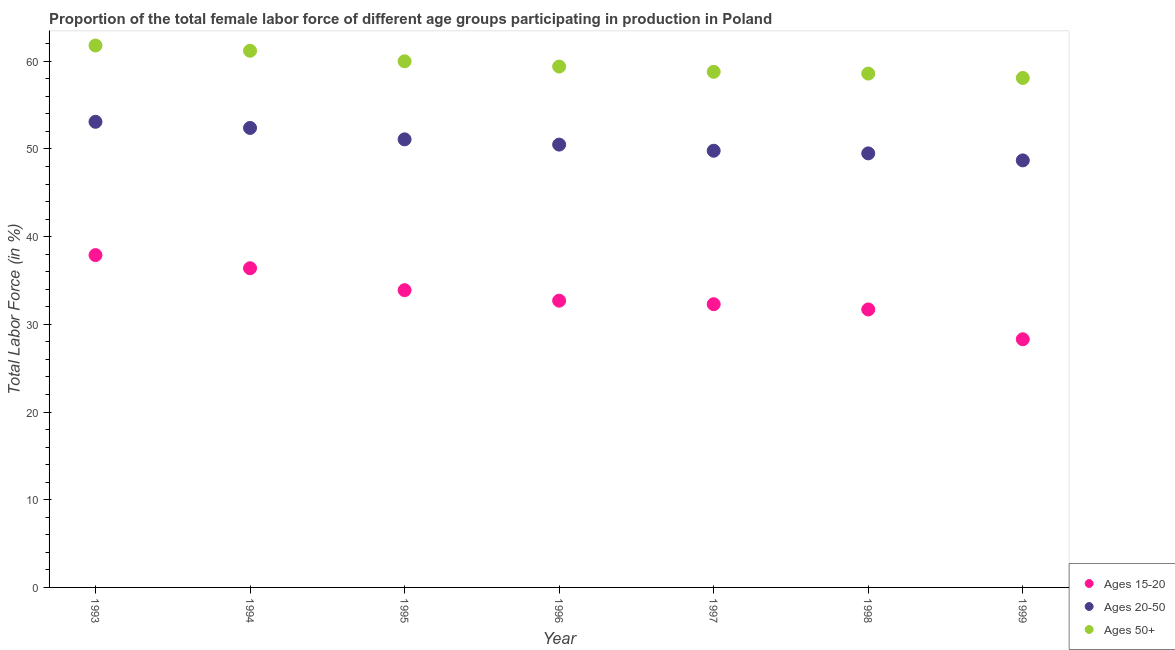How many different coloured dotlines are there?
Offer a very short reply. 3. What is the percentage of female labor force within the age group 15-20 in 1995?
Provide a succinct answer. 33.9. Across all years, what is the maximum percentage of female labor force above age 50?
Make the answer very short. 61.8. Across all years, what is the minimum percentage of female labor force within the age group 15-20?
Make the answer very short. 28.3. In which year was the percentage of female labor force within the age group 15-20 maximum?
Ensure brevity in your answer.  1993. What is the total percentage of female labor force within the age group 15-20 in the graph?
Your answer should be very brief. 233.2. What is the difference between the percentage of female labor force above age 50 in 1995 and that in 1996?
Ensure brevity in your answer.  0.6. What is the difference between the percentage of female labor force within the age group 20-50 in 1999 and the percentage of female labor force above age 50 in 1998?
Your answer should be very brief. -9.9. What is the average percentage of female labor force within the age group 20-50 per year?
Offer a very short reply. 50.73. In the year 1993, what is the difference between the percentage of female labor force within the age group 20-50 and percentage of female labor force above age 50?
Offer a very short reply. -8.7. What is the ratio of the percentage of female labor force within the age group 20-50 in 1994 to that in 1997?
Keep it short and to the point. 1.05. Is the difference between the percentage of female labor force within the age group 20-50 in 1996 and 1999 greater than the difference between the percentage of female labor force above age 50 in 1996 and 1999?
Your answer should be very brief. Yes. What is the difference between the highest and the second highest percentage of female labor force within the age group 20-50?
Your response must be concise. 0.7. What is the difference between the highest and the lowest percentage of female labor force within the age group 15-20?
Give a very brief answer. 9.6. In how many years, is the percentage of female labor force within the age group 15-20 greater than the average percentage of female labor force within the age group 15-20 taken over all years?
Offer a very short reply. 3. Is the percentage of female labor force within the age group 15-20 strictly less than the percentage of female labor force within the age group 20-50 over the years?
Provide a short and direct response. Yes. How many years are there in the graph?
Offer a very short reply. 7. What is the difference between two consecutive major ticks on the Y-axis?
Offer a terse response. 10. Are the values on the major ticks of Y-axis written in scientific E-notation?
Offer a terse response. No. Does the graph contain any zero values?
Your answer should be very brief. No. Where does the legend appear in the graph?
Offer a terse response. Bottom right. How are the legend labels stacked?
Provide a succinct answer. Vertical. What is the title of the graph?
Provide a succinct answer. Proportion of the total female labor force of different age groups participating in production in Poland. What is the label or title of the Y-axis?
Offer a very short reply. Total Labor Force (in %). What is the Total Labor Force (in %) of Ages 15-20 in 1993?
Ensure brevity in your answer.  37.9. What is the Total Labor Force (in %) in Ages 20-50 in 1993?
Your answer should be compact. 53.1. What is the Total Labor Force (in %) in Ages 50+ in 1993?
Your response must be concise. 61.8. What is the Total Labor Force (in %) in Ages 15-20 in 1994?
Make the answer very short. 36.4. What is the Total Labor Force (in %) in Ages 20-50 in 1994?
Keep it short and to the point. 52.4. What is the Total Labor Force (in %) of Ages 50+ in 1994?
Ensure brevity in your answer.  61.2. What is the Total Labor Force (in %) of Ages 15-20 in 1995?
Offer a very short reply. 33.9. What is the Total Labor Force (in %) of Ages 20-50 in 1995?
Offer a very short reply. 51.1. What is the Total Labor Force (in %) in Ages 15-20 in 1996?
Offer a terse response. 32.7. What is the Total Labor Force (in %) in Ages 20-50 in 1996?
Keep it short and to the point. 50.5. What is the Total Labor Force (in %) of Ages 50+ in 1996?
Give a very brief answer. 59.4. What is the Total Labor Force (in %) in Ages 15-20 in 1997?
Make the answer very short. 32.3. What is the Total Labor Force (in %) of Ages 20-50 in 1997?
Ensure brevity in your answer.  49.8. What is the Total Labor Force (in %) of Ages 50+ in 1997?
Provide a short and direct response. 58.8. What is the Total Labor Force (in %) of Ages 15-20 in 1998?
Keep it short and to the point. 31.7. What is the Total Labor Force (in %) of Ages 20-50 in 1998?
Offer a very short reply. 49.5. What is the Total Labor Force (in %) in Ages 50+ in 1998?
Make the answer very short. 58.6. What is the Total Labor Force (in %) of Ages 15-20 in 1999?
Your answer should be very brief. 28.3. What is the Total Labor Force (in %) in Ages 20-50 in 1999?
Ensure brevity in your answer.  48.7. What is the Total Labor Force (in %) in Ages 50+ in 1999?
Offer a very short reply. 58.1. Across all years, what is the maximum Total Labor Force (in %) in Ages 15-20?
Offer a very short reply. 37.9. Across all years, what is the maximum Total Labor Force (in %) of Ages 20-50?
Provide a short and direct response. 53.1. Across all years, what is the maximum Total Labor Force (in %) of Ages 50+?
Your answer should be very brief. 61.8. Across all years, what is the minimum Total Labor Force (in %) of Ages 15-20?
Offer a terse response. 28.3. Across all years, what is the minimum Total Labor Force (in %) of Ages 20-50?
Keep it short and to the point. 48.7. Across all years, what is the minimum Total Labor Force (in %) in Ages 50+?
Make the answer very short. 58.1. What is the total Total Labor Force (in %) in Ages 15-20 in the graph?
Provide a short and direct response. 233.2. What is the total Total Labor Force (in %) of Ages 20-50 in the graph?
Provide a short and direct response. 355.1. What is the total Total Labor Force (in %) in Ages 50+ in the graph?
Your answer should be very brief. 417.9. What is the difference between the Total Labor Force (in %) in Ages 15-20 in 1993 and that in 1994?
Ensure brevity in your answer.  1.5. What is the difference between the Total Labor Force (in %) in Ages 20-50 in 1993 and that in 1994?
Offer a very short reply. 0.7. What is the difference between the Total Labor Force (in %) of Ages 50+ in 1993 and that in 1994?
Provide a succinct answer. 0.6. What is the difference between the Total Labor Force (in %) of Ages 15-20 in 1993 and that in 1995?
Ensure brevity in your answer.  4. What is the difference between the Total Labor Force (in %) in Ages 20-50 in 1993 and that in 1995?
Make the answer very short. 2. What is the difference between the Total Labor Force (in %) of Ages 20-50 in 1993 and that in 1996?
Offer a very short reply. 2.6. What is the difference between the Total Labor Force (in %) of Ages 20-50 in 1993 and that in 1998?
Make the answer very short. 3.6. What is the difference between the Total Labor Force (in %) of Ages 50+ in 1993 and that in 1998?
Give a very brief answer. 3.2. What is the difference between the Total Labor Force (in %) of Ages 15-20 in 1994 and that in 1995?
Offer a terse response. 2.5. What is the difference between the Total Labor Force (in %) of Ages 50+ in 1994 and that in 1995?
Your answer should be compact. 1.2. What is the difference between the Total Labor Force (in %) in Ages 15-20 in 1994 and that in 1996?
Keep it short and to the point. 3.7. What is the difference between the Total Labor Force (in %) of Ages 20-50 in 1994 and that in 1996?
Offer a terse response. 1.9. What is the difference between the Total Labor Force (in %) of Ages 50+ in 1994 and that in 1996?
Make the answer very short. 1.8. What is the difference between the Total Labor Force (in %) in Ages 20-50 in 1994 and that in 1997?
Ensure brevity in your answer.  2.6. What is the difference between the Total Labor Force (in %) in Ages 15-20 in 1994 and that in 1998?
Offer a terse response. 4.7. What is the difference between the Total Labor Force (in %) in Ages 20-50 in 1994 and that in 1998?
Keep it short and to the point. 2.9. What is the difference between the Total Labor Force (in %) of Ages 50+ in 1994 and that in 1998?
Offer a terse response. 2.6. What is the difference between the Total Labor Force (in %) in Ages 15-20 in 1994 and that in 1999?
Your response must be concise. 8.1. What is the difference between the Total Labor Force (in %) of Ages 20-50 in 1995 and that in 1996?
Provide a succinct answer. 0.6. What is the difference between the Total Labor Force (in %) of Ages 50+ in 1995 and that in 1997?
Your response must be concise. 1.2. What is the difference between the Total Labor Force (in %) of Ages 15-20 in 1995 and that in 1998?
Offer a very short reply. 2.2. What is the difference between the Total Labor Force (in %) in Ages 15-20 in 1995 and that in 1999?
Keep it short and to the point. 5.6. What is the difference between the Total Labor Force (in %) of Ages 50+ in 1995 and that in 1999?
Provide a short and direct response. 1.9. What is the difference between the Total Labor Force (in %) of Ages 15-20 in 1996 and that in 1997?
Offer a terse response. 0.4. What is the difference between the Total Labor Force (in %) in Ages 50+ in 1996 and that in 1997?
Your answer should be very brief. 0.6. What is the difference between the Total Labor Force (in %) in Ages 15-20 in 1996 and that in 1998?
Your answer should be compact. 1. What is the difference between the Total Labor Force (in %) in Ages 20-50 in 1996 and that in 1998?
Keep it short and to the point. 1. What is the difference between the Total Labor Force (in %) of Ages 50+ in 1996 and that in 1998?
Make the answer very short. 0.8. What is the difference between the Total Labor Force (in %) of Ages 50+ in 1996 and that in 1999?
Your answer should be compact. 1.3. What is the difference between the Total Labor Force (in %) of Ages 15-20 in 1997 and that in 1998?
Keep it short and to the point. 0.6. What is the difference between the Total Labor Force (in %) of Ages 20-50 in 1997 and that in 1998?
Your answer should be very brief. 0.3. What is the difference between the Total Labor Force (in %) in Ages 50+ in 1997 and that in 1998?
Give a very brief answer. 0.2. What is the difference between the Total Labor Force (in %) in Ages 20-50 in 1998 and that in 1999?
Provide a succinct answer. 0.8. What is the difference between the Total Labor Force (in %) of Ages 15-20 in 1993 and the Total Labor Force (in %) of Ages 20-50 in 1994?
Make the answer very short. -14.5. What is the difference between the Total Labor Force (in %) of Ages 15-20 in 1993 and the Total Labor Force (in %) of Ages 50+ in 1994?
Give a very brief answer. -23.3. What is the difference between the Total Labor Force (in %) in Ages 15-20 in 1993 and the Total Labor Force (in %) in Ages 50+ in 1995?
Offer a very short reply. -22.1. What is the difference between the Total Labor Force (in %) of Ages 15-20 in 1993 and the Total Labor Force (in %) of Ages 50+ in 1996?
Give a very brief answer. -21.5. What is the difference between the Total Labor Force (in %) of Ages 15-20 in 1993 and the Total Labor Force (in %) of Ages 50+ in 1997?
Provide a succinct answer. -20.9. What is the difference between the Total Labor Force (in %) of Ages 20-50 in 1993 and the Total Labor Force (in %) of Ages 50+ in 1997?
Ensure brevity in your answer.  -5.7. What is the difference between the Total Labor Force (in %) of Ages 15-20 in 1993 and the Total Labor Force (in %) of Ages 50+ in 1998?
Your response must be concise. -20.7. What is the difference between the Total Labor Force (in %) in Ages 15-20 in 1993 and the Total Labor Force (in %) in Ages 20-50 in 1999?
Your response must be concise. -10.8. What is the difference between the Total Labor Force (in %) of Ages 15-20 in 1993 and the Total Labor Force (in %) of Ages 50+ in 1999?
Make the answer very short. -20.2. What is the difference between the Total Labor Force (in %) of Ages 15-20 in 1994 and the Total Labor Force (in %) of Ages 20-50 in 1995?
Keep it short and to the point. -14.7. What is the difference between the Total Labor Force (in %) of Ages 15-20 in 1994 and the Total Labor Force (in %) of Ages 50+ in 1995?
Provide a short and direct response. -23.6. What is the difference between the Total Labor Force (in %) in Ages 15-20 in 1994 and the Total Labor Force (in %) in Ages 20-50 in 1996?
Your response must be concise. -14.1. What is the difference between the Total Labor Force (in %) of Ages 15-20 in 1994 and the Total Labor Force (in %) of Ages 50+ in 1996?
Make the answer very short. -23. What is the difference between the Total Labor Force (in %) of Ages 20-50 in 1994 and the Total Labor Force (in %) of Ages 50+ in 1996?
Your answer should be very brief. -7. What is the difference between the Total Labor Force (in %) in Ages 15-20 in 1994 and the Total Labor Force (in %) in Ages 50+ in 1997?
Keep it short and to the point. -22.4. What is the difference between the Total Labor Force (in %) of Ages 15-20 in 1994 and the Total Labor Force (in %) of Ages 20-50 in 1998?
Provide a succinct answer. -13.1. What is the difference between the Total Labor Force (in %) in Ages 15-20 in 1994 and the Total Labor Force (in %) in Ages 50+ in 1998?
Ensure brevity in your answer.  -22.2. What is the difference between the Total Labor Force (in %) of Ages 20-50 in 1994 and the Total Labor Force (in %) of Ages 50+ in 1998?
Provide a succinct answer. -6.2. What is the difference between the Total Labor Force (in %) of Ages 15-20 in 1994 and the Total Labor Force (in %) of Ages 20-50 in 1999?
Provide a succinct answer. -12.3. What is the difference between the Total Labor Force (in %) of Ages 15-20 in 1994 and the Total Labor Force (in %) of Ages 50+ in 1999?
Ensure brevity in your answer.  -21.7. What is the difference between the Total Labor Force (in %) of Ages 15-20 in 1995 and the Total Labor Force (in %) of Ages 20-50 in 1996?
Offer a very short reply. -16.6. What is the difference between the Total Labor Force (in %) of Ages 15-20 in 1995 and the Total Labor Force (in %) of Ages 50+ in 1996?
Give a very brief answer. -25.5. What is the difference between the Total Labor Force (in %) of Ages 20-50 in 1995 and the Total Labor Force (in %) of Ages 50+ in 1996?
Provide a succinct answer. -8.3. What is the difference between the Total Labor Force (in %) in Ages 15-20 in 1995 and the Total Labor Force (in %) in Ages 20-50 in 1997?
Offer a very short reply. -15.9. What is the difference between the Total Labor Force (in %) of Ages 15-20 in 1995 and the Total Labor Force (in %) of Ages 50+ in 1997?
Ensure brevity in your answer.  -24.9. What is the difference between the Total Labor Force (in %) in Ages 15-20 in 1995 and the Total Labor Force (in %) in Ages 20-50 in 1998?
Keep it short and to the point. -15.6. What is the difference between the Total Labor Force (in %) in Ages 15-20 in 1995 and the Total Labor Force (in %) in Ages 50+ in 1998?
Your response must be concise. -24.7. What is the difference between the Total Labor Force (in %) of Ages 20-50 in 1995 and the Total Labor Force (in %) of Ages 50+ in 1998?
Your answer should be very brief. -7.5. What is the difference between the Total Labor Force (in %) of Ages 15-20 in 1995 and the Total Labor Force (in %) of Ages 20-50 in 1999?
Your answer should be very brief. -14.8. What is the difference between the Total Labor Force (in %) of Ages 15-20 in 1995 and the Total Labor Force (in %) of Ages 50+ in 1999?
Provide a succinct answer. -24.2. What is the difference between the Total Labor Force (in %) in Ages 15-20 in 1996 and the Total Labor Force (in %) in Ages 20-50 in 1997?
Give a very brief answer. -17.1. What is the difference between the Total Labor Force (in %) in Ages 15-20 in 1996 and the Total Labor Force (in %) in Ages 50+ in 1997?
Give a very brief answer. -26.1. What is the difference between the Total Labor Force (in %) in Ages 20-50 in 1996 and the Total Labor Force (in %) in Ages 50+ in 1997?
Your answer should be compact. -8.3. What is the difference between the Total Labor Force (in %) in Ages 15-20 in 1996 and the Total Labor Force (in %) in Ages 20-50 in 1998?
Ensure brevity in your answer.  -16.8. What is the difference between the Total Labor Force (in %) of Ages 15-20 in 1996 and the Total Labor Force (in %) of Ages 50+ in 1998?
Provide a short and direct response. -25.9. What is the difference between the Total Labor Force (in %) in Ages 20-50 in 1996 and the Total Labor Force (in %) in Ages 50+ in 1998?
Your answer should be compact. -8.1. What is the difference between the Total Labor Force (in %) of Ages 15-20 in 1996 and the Total Labor Force (in %) of Ages 20-50 in 1999?
Make the answer very short. -16. What is the difference between the Total Labor Force (in %) in Ages 15-20 in 1996 and the Total Labor Force (in %) in Ages 50+ in 1999?
Offer a very short reply. -25.4. What is the difference between the Total Labor Force (in %) of Ages 20-50 in 1996 and the Total Labor Force (in %) of Ages 50+ in 1999?
Your answer should be compact. -7.6. What is the difference between the Total Labor Force (in %) of Ages 15-20 in 1997 and the Total Labor Force (in %) of Ages 20-50 in 1998?
Give a very brief answer. -17.2. What is the difference between the Total Labor Force (in %) in Ages 15-20 in 1997 and the Total Labor Force (in %) in Ages 50+ in 1998?
Provide a succinct answer. -26.3. What is the difference between the Total Labor Force (in %) of Ages 20-50 in 1997 and the Total Labor Force (in %) of Ages 50+ in 1998?
Give a very brief answer. -8.8. What is the difference between the Total Labor Force (in %) of Ages 15-20 in 1997 and the Total Labor Force (in %) of Ages 20-50 in 1999?
Provide a succinct answer. -16.4. What is the difference between the Total Labor Force (in %) of Ages 15-20 in 1997 and the Total Labor Force (in %) of Ages 50+ in 1999?
Make the answer very short. -25.8. What is the difference between the Total Labor Force (in %) in Ages 15-20 in 1998 and the Total Labor Force (in %) in Ages 20-50 in 1999?
Provide a succinct answer. -17. What is the difference between the Total Labor Force (in %) in Ages 15-20 in 1998 and the Total Labor Force (in %) in Ages 50+ in 1999?
Provide a short and direct response. -26.4. What is the difference between the Total Labor Force (in %) in Ages 20-50 in 1998 and the Total Labor Force (in %) in Ages 50+ in 1999?
Make the answer very short. -8.6. What is the average Total Labor Force (in %) of Ages 15-20 per year?
Keep it short and to the point. 33.31. What is the average Total Labor Force (in %) of Ages 20-50 per year?
Offer a very short reply. 50.73. What is the average Total Labor Force (in %) in Ages 50+ per year?
Provide a short and direct response. 59.7. In the year 1993, what is the difference between the Total Labor Force (in %) of Ages 15-20 and Total Labor Force (in %) of Ages 20-50?
Your answer should be compact. -15.2. In the year 1993, what is the difference between the Total Labor Force (in %) in Ages 15-20 and Total Labor Force (in %) in Ages 50+?
Provide a short and direct response. -23.9. In the year 1994, what is the difference between the Total Labor Force (in %) of Ages 15-20 and Total Labor Force (in %) of Ages 50+?
Keep it short and to the point. -24.8. In the year 1995, what is the difference between the Total Labor Force (in %) in Ages 15-20 and Total Labor Force (in %) in Ages 20-50?
Give a very brief answer. -17.2. In the year 1995, what is the difference between the Total Labor Force (in %) in Ages 15-20 and Total Labor Force (in %) in Ages 50+?
Ensure brevity in your answer.  -26.1. In the year 1995, what is the difference between the Total Labor Force (in %) in Ages 20-50 and Total Labor Force (in %) in Ages 50+?
Keep it short and to the point. -8.9. In the year 1996, what is the difference between the Total Labor Force (in %) in Ages 15-20 and Total Labor Force (in %) in Ages 20-50?
Provide a succinct answer. -17.8. In the year 1996, what is the difference between the Total Labor Force (in %) in Ages 15-20 and Total Labor Force (in %) in Ages 50+?
Offer a very short reply. -26.7. In the year 1997, what is the difference between the Total Labor Force (in %) in Ages 15-20 and Total Labor Force (in %) in Ages 20-50?
Ensure brevity in your answer.  -17.5. In the year 1997, what is the difference between the Total Labor Force (in %) of Ages 15-20 and Total Labor Force (in %) of Ages 50+?
Your answer should be very brief. -26.5. In the year 1997, what is the difference between the Total Labor Force (in %) in Ages 20-50 and Total Labor Force (in %) in Ages 50+?
Offer a very short reply. -9. In the year 1998, what is the difference between the Total Labor Force (in %) of Ages 15-20 and Total Labor Force (in %) of Ages 20-50?
Your answer should be very brief. -17.8. In the year 1998, what is the difference between the Total Labor Force (in %) of Ages 15-20 and Total Labor Force (in %) of Ages 50+?
Provide a succinct answer. -26.9. In the year 1998, what is the difference between the Total Labor Force (in %) in Ages 20-50 and Total Labor Force (in %) in Ages 50+?
Your response must be concise. -9.1. In the year 1999, what is the difference between the Total Labor Force (in %) in Ages 15-20 and Total Labor Force (in %) in Ages 20-50?
Your answer should be very brief. -20.4. In the year 1999, what is the difference between the Total Labor Force (in %) in Ages 15-20 and Total Labor Force (in %) in Ages 50+?
Keep it short and to the point. -29.8. What is the ratio of the Total Labor Force (in %) in Ages 15-20 in 1993 to that in 1994?
Keep it short and to the point. 1.04. What is the ratio of the Total Labor Force (in %) of Ages 20-50 in 1993 to that in 1994?
Your answer should be compact. 1.01. What is the ratio of the Total Labor Force (in %) of Ages 50+ in 1993 to that in 1994?
Keep it short and to the point. 1.01. What is the ratio of the Total Labor Force (in %) of Ages 15-20 in 1993 to that in 1995?
Your response must be concise. 1.12. What is the ratio of the Total Labor Force (in %) in Ages 20-50 in 1993 to that in 1995?
Offer a very short reply. 1.04. What is the ratio of the Total Labor Force (in %) in Ages 50+ in 1993 to that in 1995?
Your response must be concise. 1.03. What is the ratio of the Total Labor Force (in %) of Ages 15-20 in 1993 to that in 1996?
Keep it short and to the point. 1.16. What is the ratio of the Total Labor Force (in %) of Ages 20-50 in 1993 to that in 1996?
Make the answer very short. 1.05. What is the ratio of the Total Labor Force (in %) of Ages 50+ in 1993 to that in 1996?
Offer a terse response. 1.04. What is the ratio of the Total Labor Force (in %) of Ages 15-20 in 1993 to that in 1997?
Your answer should be very brief. 1.17. What is the ratio of the Total Labor Force (in %) in Ages 20-50 in 1993 to that in 1997?
Ensure brevity in your answer.  1.07. What is the ratio of the Total Labor Force (in %) of Ages 50+ in 1993 to that in 1997?
Your answer should be very brief. 1.05. What is the ratio of the Total Labor Force (in %) of Ages 15-20 in 1993 to that in 1998?
Offer a very short reply. 1.2. What is the ratio of the Total Labor Force (in %) in Ages 20-50 in 1993 to that in 1998?
Your answer should be very brief. 1.07. What is the ratio of the Total Labor Force (in %) in Ages 50+ in 1993 to that in 1998?
Give a very brief answer. 1.05. What is the ratio of the Total Labor Force (in %) in Ages 15-20 in 1993 to that in 1999?
Provide a succinct answer. 1.34. What is the ratio of the Total Labor Force (in %) in Ages 20-50 in 1993 to that in 1999?
Make the answer very short. 1.09. What is the ratio of the Total Labor Force (in %) in Ages 50+ in 1993 to that in 1999?
Your response must be concise. 1.06. What is the ratio of the Total Labor Force (in %) of Ages 15-20 in 1994 to that in 1995?
Ensure brevity in your answer.  1.07. What is the ratio of the Total Labor Force (in %) in Ages 20-50 in 1994 to that in 1995?
Provide a succinct answer. 1.03. What is the ratio of the Total Labor Force (in %) in Ages 50+ in 1994 to that in 1995?
Ensure brevity in your answer.  1.02. What is the ratio of the Total Labor Force (in %) in Ages 15-20 in 1994 to that in 1996?
Ensure brevity in your answer.  1.11. What is the ratio of the Total Labor Force (in %) of Ages 20-50 in 1994 to that in 1996?
Provide a succinct answer. 1.04. What is the ratio of the Total Labor Force (in %) in Ages 50+ in 1994 to that in 1996?
Keep it short and to the point. 1.03. What is the ratio of the Total Labor Force (in %) of Ages 15-20 in 1994 to that in 1997?
Offer a terse response. 1.13. What is the ratio of the Total Labor Force (in %) of Ages 20-50 in 1994 to that in 1997?
Give a very brief answer. 1.05. What is the ratio of the Total Labor Force (in %) in Ages 50+ in 1994 to that in 1997?
Keep it short and to the point. 1.04. What is the ratio of the Total Labor Force (in %) of Ages 15-20 in 1994 to that in 1998?
Provide a succinct answer. 1.15. What is the ratio of the Total Labor Force (in %) in Ages 20-50 in 1994 to that in 1998?
Give a very brief answer. 1.06. What is the ratio of the Total Labor Force (in %) in Ages 50+ in 1994 to that in 1998?
Give a very brief answer. 1.04. What is the ratio of the Total Labor Force (in %) in Ages 15-20 in 1994 to that in 1999?
Offer a terse response. 1.29. What is the ratio of the Total Labor Force (in %) in Ages 20-50 in 1994 to that in 1999?
Ensure brevity in your answer.  1.08. What is the ratio of the Total Labor Force (in %) of Ages 50+ in 1994 to that in 1999?
Ensure brevity in your answer.  1.05. What is the ratio of the Total Labor Force (in %) in Ages 15-20 in 1995 to that in 1996?
Give a very brief answer. 1.04. What is the ratio of the Total Labor Force (in %) of Ages 20-50 in 1995 to that in 1996?
Ensure brevity in your answer.  1.01. What is the ratio of the Total Labor Force (in %) in Ages 15-20 in 1995 to that in 1997?
Give a very brief answer. 1.05. What is the ratio of the Total Labor Force (in %) of Ages 20-50 in 1995 to that in 1997?
Keep it short and to the point. 1.03. What is the ratio of the Total Labor Force (in %) in Ages 50+ in 1995 to that in 1997?
Offer a very short reply. 1.02. What is the ratio of the Total Labor Force (in %) of Ages 15-20 in 1995 to that in 1998?
Ensure brevity in your answer.  1.07. What is the ratio of the Total Labor Force (in %) of Ages 20-50 in 1995 to that in 1998?
Your response must be concise. 1.03. What is the ratio of the Total Labor Force (in %) of Ages 50+ in 1995 to that in 1998?
Your response must be concise. 1.02. What is the ratio of the Total Labor Force (in %) of Ages 15-20 in 1995 to that in 1999?
Your answer should be compact. 1.2. What is the ratio of the Total Labor Force (in %) of Ages 20-50 in 1995 to that in 1999?
Provide a short and direct response. 1.05. What is the ratio of the Total Labor Force (in %) of Ages 50+ in 1995 to that in 1999?
Your response must be concise. 1.03. What is the ratio of the Total Labor Force (in %) in Ages 15-20 in 1996 to that in 1997?
Your answer should be compact. 1.01. What is the ratio of the Total Labor Force (in %) of Ages 20-50 in 1996 to that in 1997?
Provide a succinct answer. 1.01. What is the ratio of the Total Labor Force (in %) of Ages 50+ in 1996 to that in 1997?
Offer a terse response. 1.01. What is the ratio of the Total Labor Force (in %) of Ages 15-20 in 1996 to that in 1998?
Provide a short and direct response. 1.03. What is the ratio of the Total Labor Force (in %) in Ages 20-50 in 1996 to that in 1998?
Your answer should be compact. 1.02. What is the ratio of the Total Labor Force (in %) in Ages 50+ in 1996 to that in 1998?
Offer a very short reply. 1.01. What is the ratio of the Total Labor Force (in %) of Ages 15-20 in 1996 to that in 1999?
Provide a short and direct response. 1.16. What is the ratio of the Total Labor Force (in %) of Ages 50+ in 1996 to that in 1999?
Make the answer very short. 1.02. What is the ratio of the Total Labor Force (in %) of Ages 15-20 in 1997 to that in 1998?
Provide a succinct answer. 1.02. What is the ratio of the Total Labor Force (in %) of Ages 50+ in 1997 to that in 1998?
Offer a terse response. 1. What is the ratio of the Total Labor Force (in %) in Ages 15-20 in 1997 to that in 1999?
Your response must be concise. 1.14. What is the ratio of the Total Labor Force (in %) in Ages 20-50 in 1997 to that in 1999?
Your answer should be very brief. 1.02. What is the ratio of the Total Labor Force (in %) of Ages 15-20 in 1998 to that in 1999?
Provide a short and direct response. 1.12. What is the ratio of the Total Labor Force (in %) of Ages 20-50 in 1998 to that in 1999?
Your answer should be compact. 1.02. What is the ratio of the Total Labor Force (in %) of Ages 50+ in 1998 to that in 1999?
Your response must be concise. 1.01. What is the difference between the highest and the second highest Total Labor Force (in %) of Ages 50+?
Provide a succinct answer. 0.6. What is the difference between the highest and the lowest Total Labor Force (in %) in Ages 50+?
Provide a succinct answer. 3.7. 